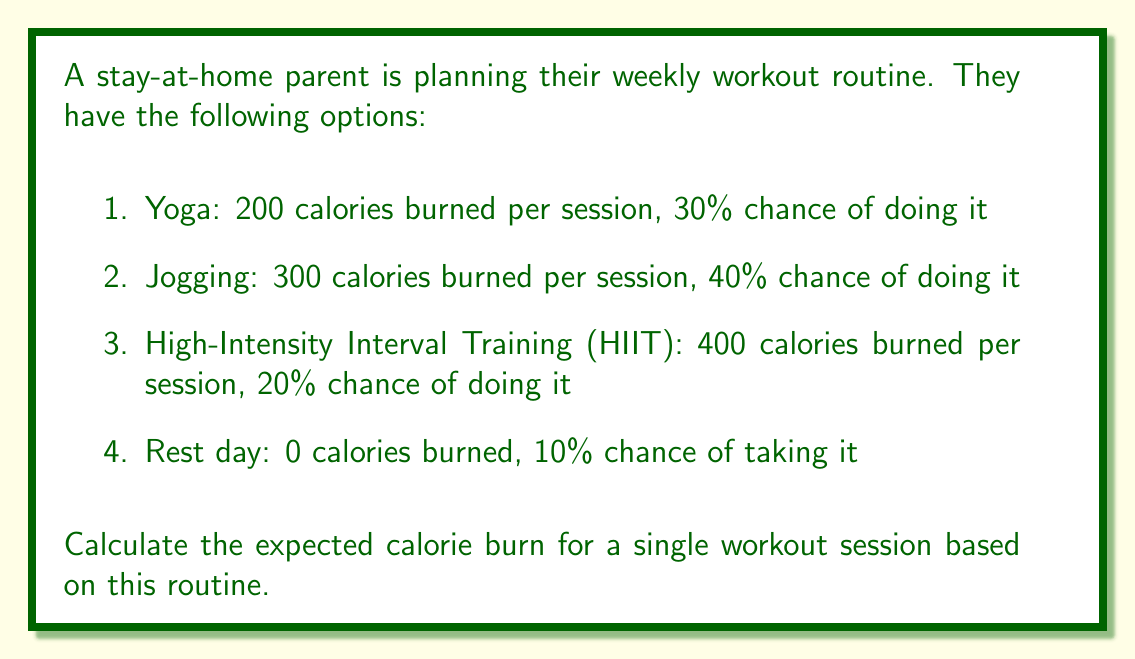Could you help me with this problem? To calculate the expected calorie burn, we need to use the concept of expected value. The expected value is the sum of each possible outcome multiplied by its probability.

Let's break it down step-by-step:

1. For each workout option, we'll multiply the calorie burn by its probability:

   Yoga: $200 \times 0.30 = 60$ calories
   Jogging: $300 \times 0.40 = 120$ calories
   HIIT: $400 \times 0.20 = 80$ calories
   Rest day: $0 \times 0.10 = 0$ calories

2. Now, we sum up all these values:

   $$ \text{Expected Calorie Burn} = 60 + 120 + 80 + 0 = 260 \text{ calories} $$

Therefore, the expected calorie burn for a single workout session based on this routine is 260 calories.
Answer: 260 calories 